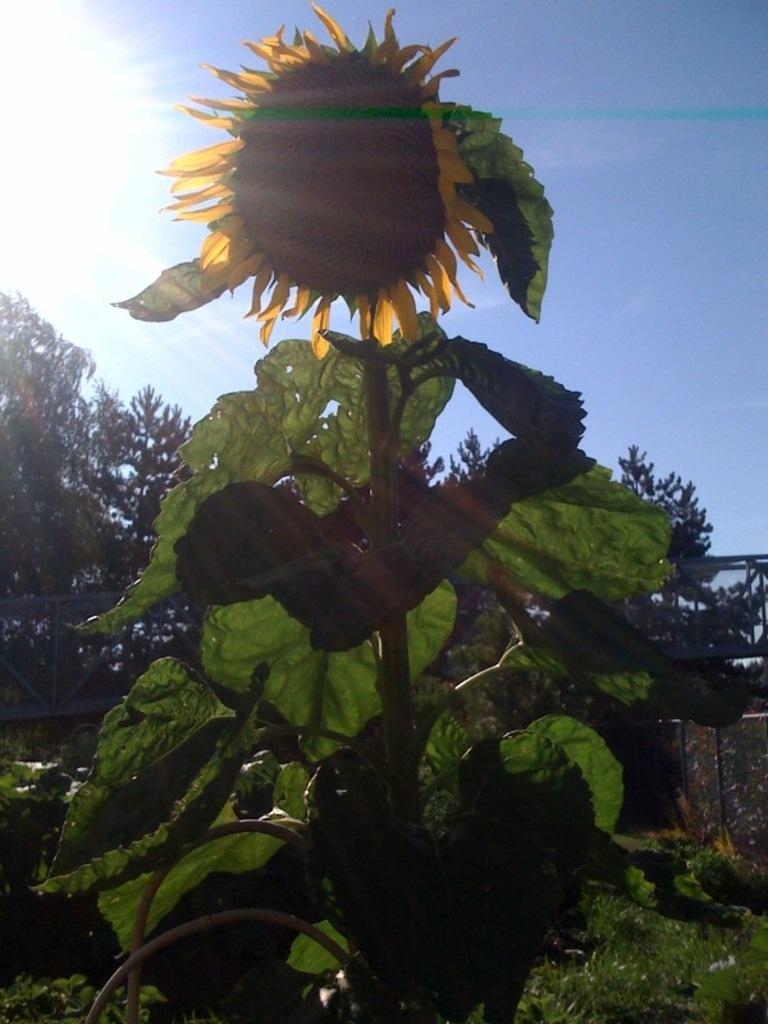What type of plant can be seen in the image? There is a plant with a flower in the image. What other vegetation is present in the image? There are trees in the image. What can be seen in the background of the image? The sky is visible in the background of the image. Where is the goat located in the image? There is no goat present in the image. What type of bird can be seen flying in the image? There is no bird visible in the image. 